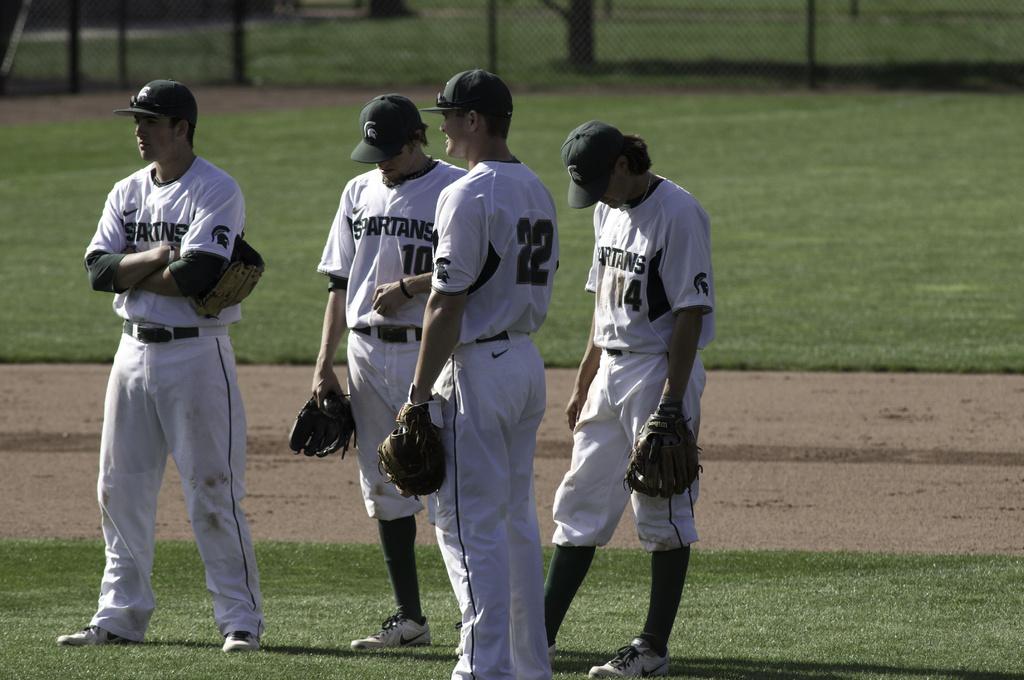What baseball team is this?
Your answer should be very brief. Spartans. What is the player number who is facing away?
Your response must be concise. 22. 